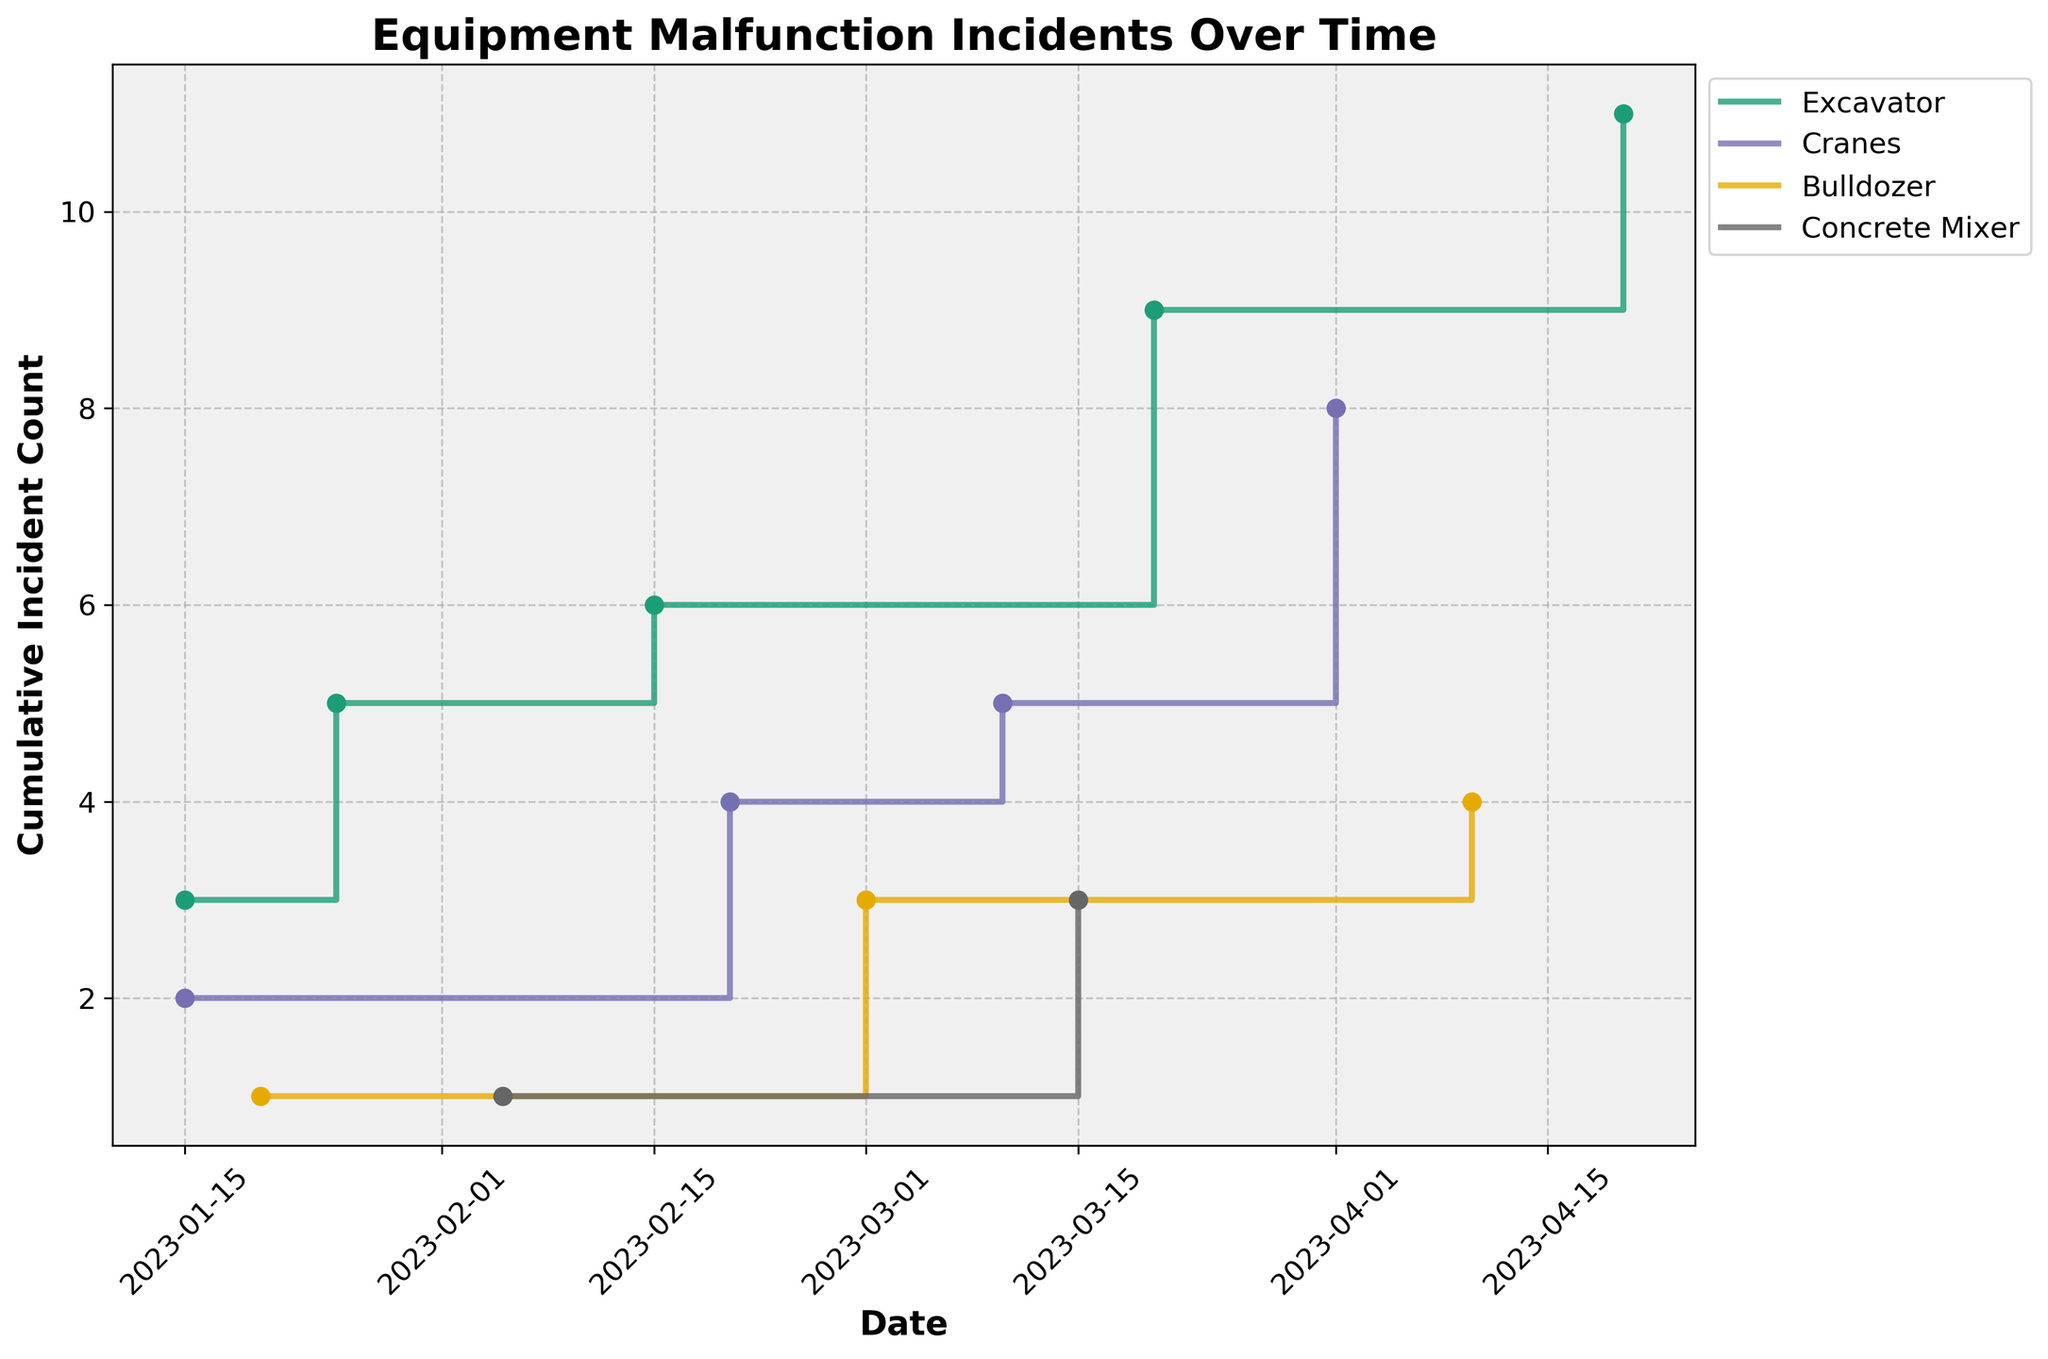what is the title of the plot? The title is located at the top of the plot; it's written in a bold, larger font compared to other text elements, making it easily distinguishable.
Answer: Equipment Malfunction Incidents Over Time what are the labels for the x-axis and y-axis? The labels for the axes are typically placed alongside the respective axis. The x-axis label is found below the horizontal axis, and the y-axis label is found beside the vertical axis.
Answer: Date (x-axis), Cumulative Incident Count (y-axis) how many different equipment types are plotted? The number of different equipment types can be determined by the number of lines and legends present in the plot. Each unique line represents a different equipment type.
Answer: 4 which equipment type has the highest cumulative incident count by the end of the time period? To find the equipment type with the highest cumulative incident count, look for the line that reaches the highest point on the y-axis by the end of the plot.
Answer: Cranes on which date did the cumulative incident count for 'Excavator' increase by 3 incidents? Observe the points on the plot for 'Excavator' and identify where the line increases by 3 units vertically. Then, check the corresponding date on the x-axis.
Answer: 2023-03-20 how many incidents were reported for 'Concrete Mixer' by the end of March? Locate the last point for 'Concrete Mixer' in March on the plot, read the y-axis to get the cumulative count, and add all incidents reported up to that date.
Answer: 3 compare the cumulative incidents between 'Bulldozer' and 'Cranes' at the end of February. which had more? Compare the y-axis values for the lines representing 'Bulldozer' and 'Cranes' on the plot as of the last date in February.
Answer: Cranes when did the cumulative incident counts for 'Excavator' and 'Cranes' become equal? Look for the point where the lines for 'Excavator' and 'Cranes' intersect; read the corresponding date from the x-axis.
Answer: They do not become equal what is the difference in cumulative incidents between 'Bulldozer' and 'Concrete Mixer' by mid-March? By mid-March (2023-03-15), identify the cumulative incident counts for both 'Bulldozer' and 'Concrete Mixer' from the y-axis and then calculate the difference.
Answer: 1 (4 for Bulldozer - 3 for Concrete Mixer) which equipment type had a consistent increase in incidents without any plateau? Look for a line that continuously rises without any horizontal segments, indicating consistent increases.
Answer: Bulldozer 